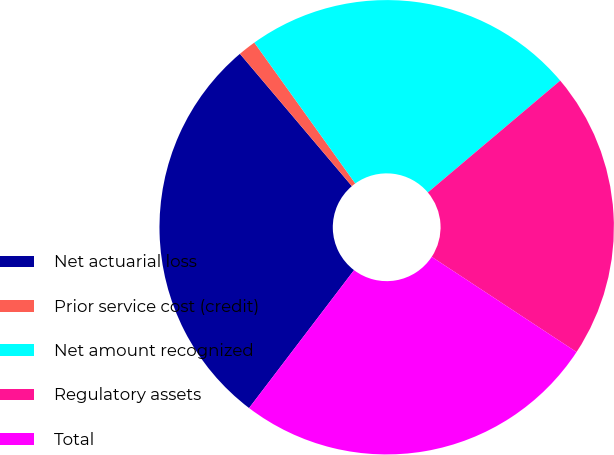Convert chart. <chart><loc_0><loc_0><loc_500><loc_500><pie_chart><fcel>Net actuarial loss<fcel>Prior service cost (credit)<fcel>Net amount recognized<fcel>Regulatory assets<fcel>Total<nl><fcel>28.47%<fcel>1.28%<fcel>23.73%<fcel>20.42%<fcel>26.1%<nl></chart> 